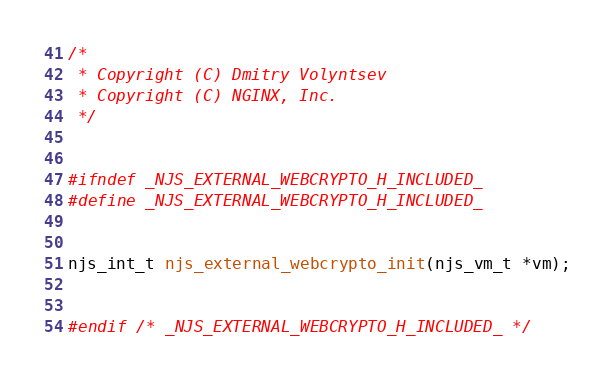Convert code to text. <code><loc_0><loc_0><loc_500><loc_500><_C_>
/*
 * Copyright (C) Dmitry Volyntsev
 * Copyright (C) NGINX, Inc.
 */


#ifndef _NJS_EXTERNAL_WEBCRYPTO_H_INCLUDED_
#define _NJS_EXTERNAL_WEBCRYPTO_H_INCLUDED_


njs_int_t njs_external_webcrypto_init(njs_vm_t *vm);


#endif /* _NJS_EXTERNAL_WEBCRYPTO_H_INCLUDED_ */
</code> 